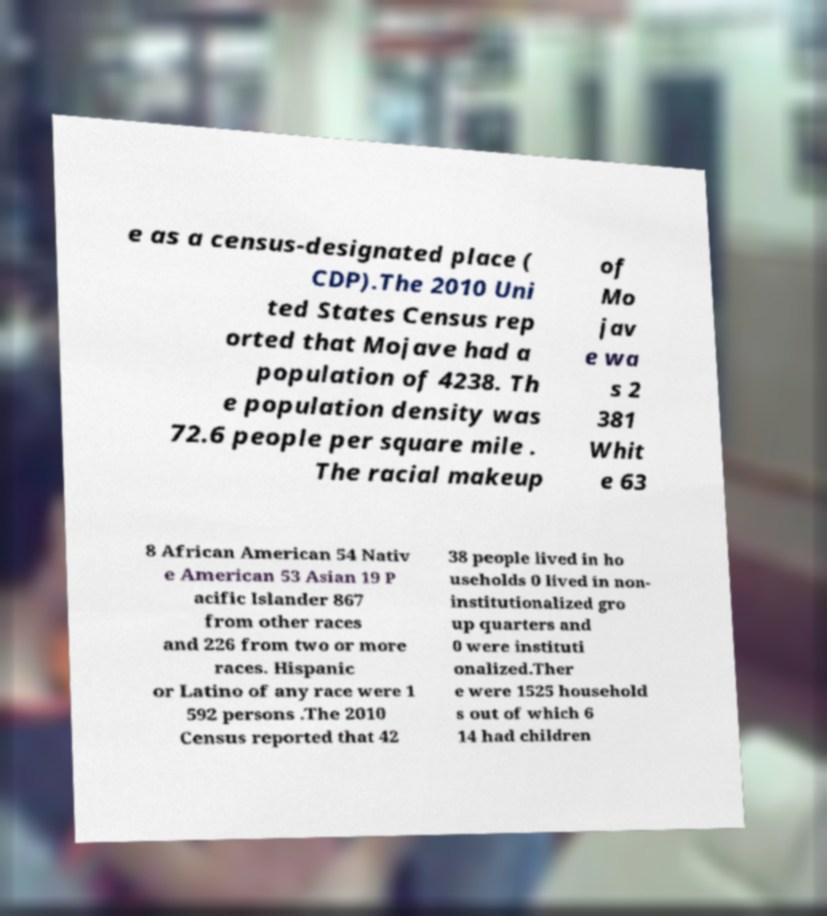What messages or text are displayed in this image? I need them in a readable, typed format. e as a census-designated place ( CDP).The 2010 Uni ted States Census rep orted that Mojave had a population of 4238. Th e population density was 72.6 people per square mile . The racial makeup of Mo jav e wa s 2 381 Whit e 63 8 African American 54 Nativ e American 53 Asian 19 P acific Islander 867 from other races and 226 from two or more races. Hispanic or Latino of any race were 1 592 persons .The 2010 Census reported that 42 38 people lived in ho useholds 0 lived in non- institutionalized gro up quarters and 0 were instituti onalized.Ther e were 1525 household s out of which 6 14 had children 